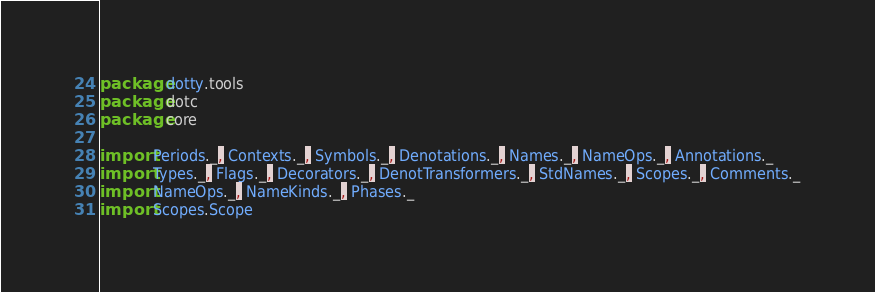Convert code to text. <code><loc_0><loc_0><loc_500><loc_500><_Scala_>package dotty.tools
package dotc
package core

import Periods._, Contexts._, Symbols._, Denotations._, Names._, NameOps._, Annotations._
import Types._, Flags._, Decorators._, DenotTransformers._, StdNames._, Scopes._, Comments._
import NameOps._, NameKinds._, Phases._
import Scopes.Scope</code> 